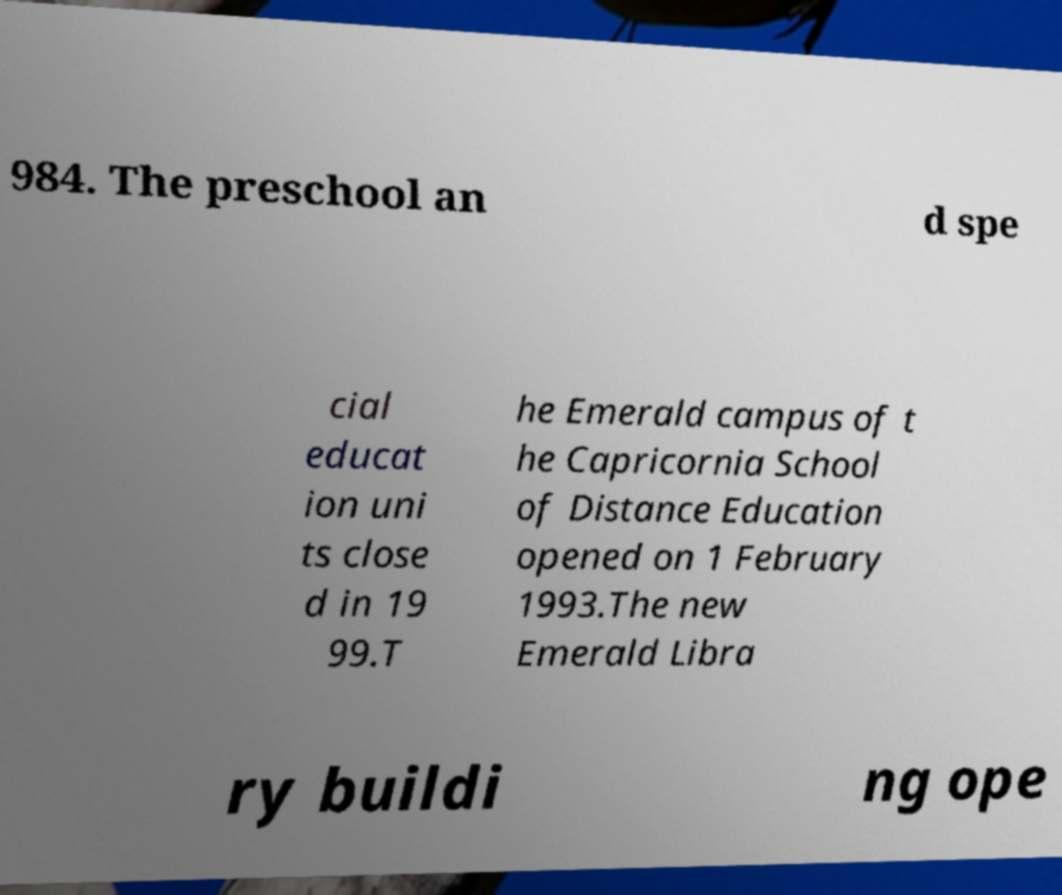There's text embedded in this image that I need extracted. Can you transcribe it verbatim? 984. The preschool an d spe cial educat ion uni ts close d in 19 99.T he Emerald campus of t he Capricornia School of Distance Education opened on 1 February 1993.The new Emerald Libra ry buildi ng ope 